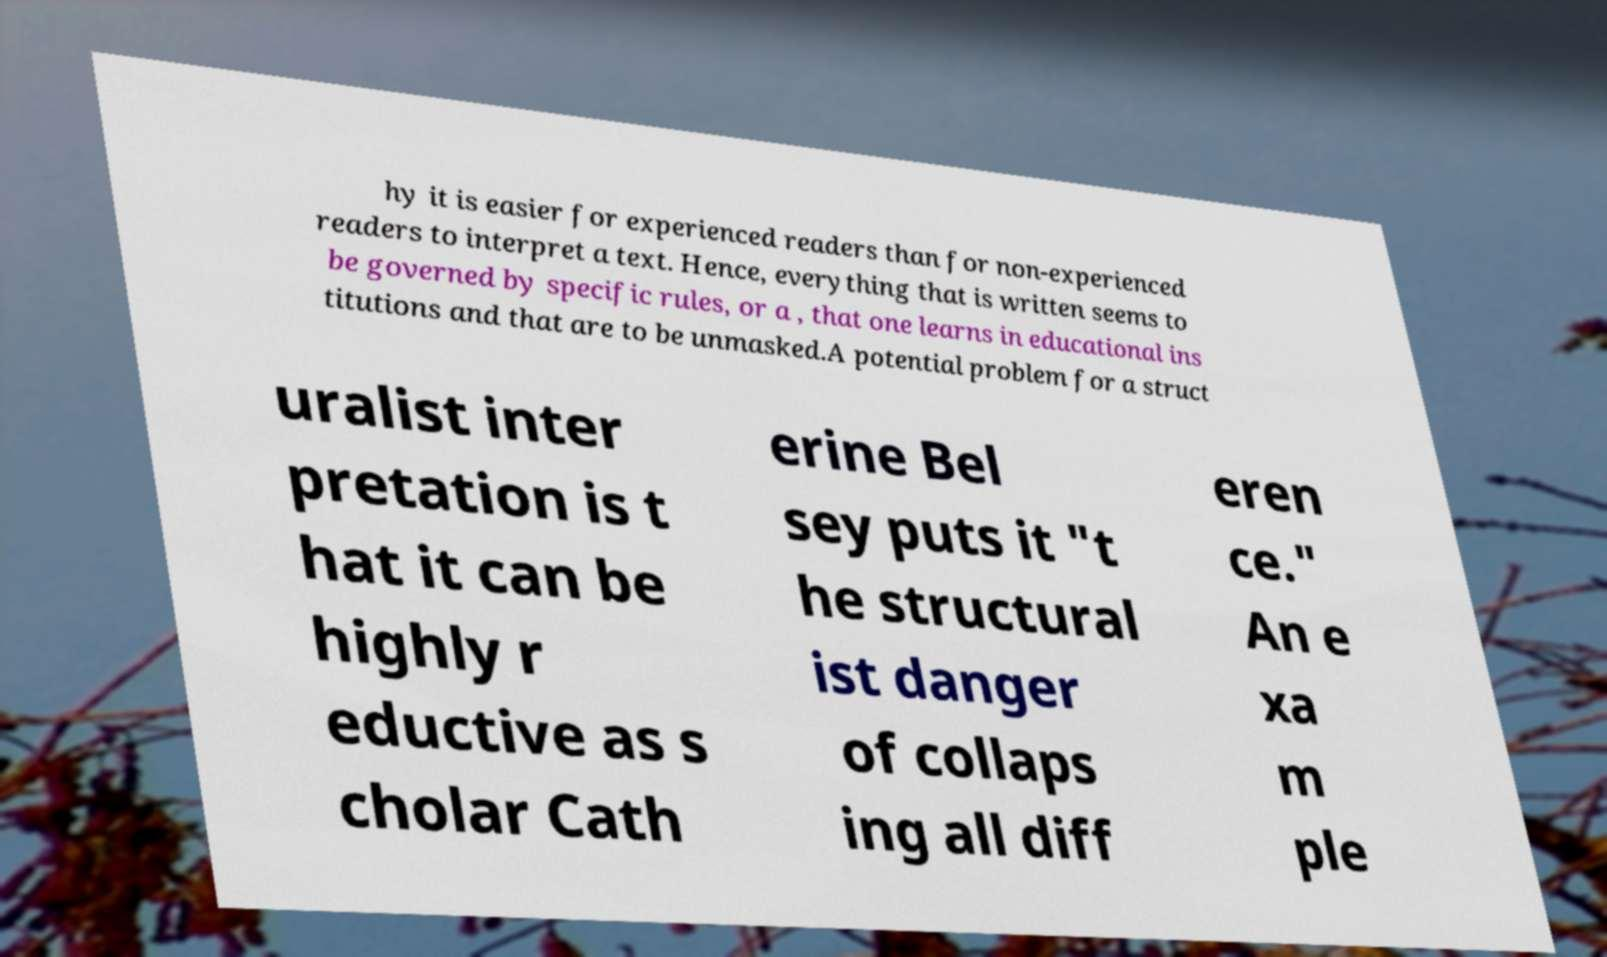Could you extract and type out the text from this image? hy it is easier for experienced readers than for non-experienced readers to interpret a text. Hence, everything that is written seems to be governed by specific rules, or a , that one learns in educational ins titutions and that are to be unmasked.A potential problem for a struct uralist inter pretation is t hat it can be highly r eductive as s cholar Cath erine Bel sey puts it "t he structural ist danger of collaps ing all diff eren ce." An e xa m ple 